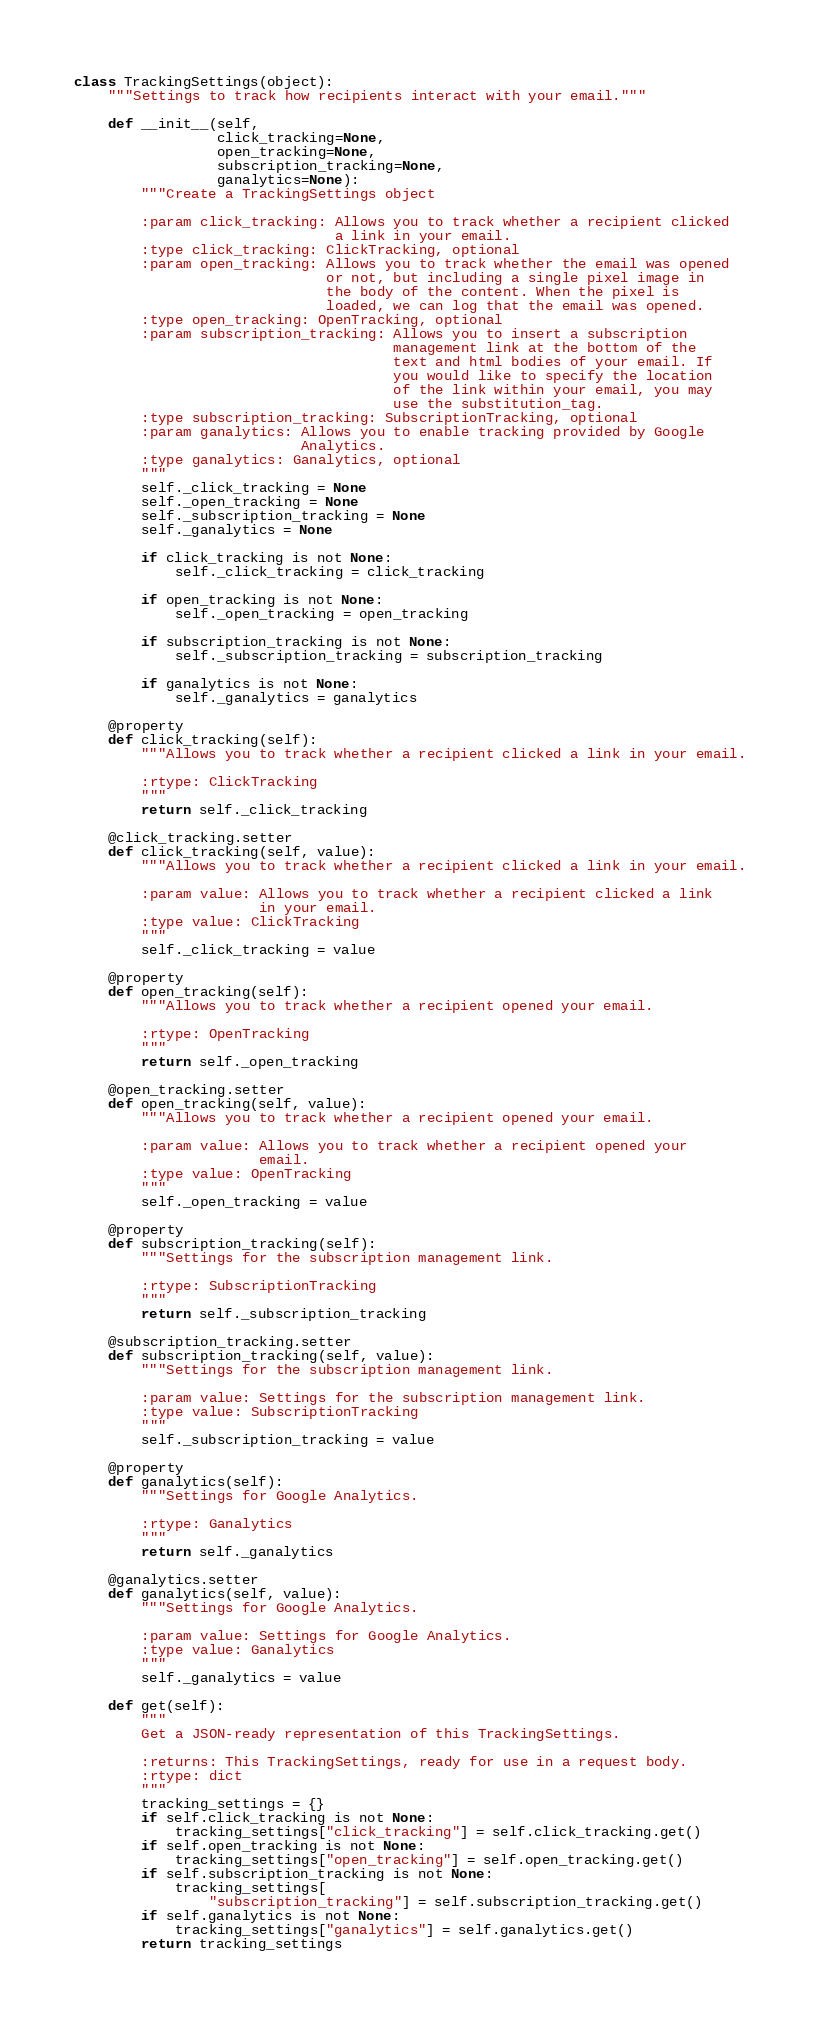Convert code to text. <code><loc_0><loc_0><loc_500><loc_500><_Python_>class TrackingSettings(object):
    """Settings to track how recipients interact with your email."""

    def __init__(self,
                 click_tracking=None,
                 open_tracking=None,
                 subscription_tracking=None,
                 ganalytics=None):
        """Create a TrackingSettings object

        :param click_tracking: Allows you to track whether a recipient clicked
                               a link in your email.
        :type click_tracking: ClickTracking, optional
        :param open_tracking: Allows you to track whether the email was opened
                              or not, but including a single pixel image in
                              the body of the content. When the pixel is
                              loaded, we can log that the email was opened.
        :type open_tracking: OpenTracking, optional
        :param subscription_tracking: Allows you to insert a subscription
                                      management link at the bottom of the
                                      text and html bodies of your email. If
                                      you would like to specify the location
                                      of the link within your email, you may
                                      use the substitution_tag.
        :type subscription_tracking: SubscriptionTracking, optional
        :param ganalytics: Allows you to enable tracking provided by Google
                           Analytics.
        :type ganalytics: Ganalytics, optional
        """
        self._click_tracking = None
        self._open_tracking = None
        self._subscription_tracking = None
        self._ganalytics = None

        if click_tracking is not None:
            self._click_tracking = click_tracking

        if open_tracking is not None:
            self._open_tracking = open_tracking

        if subscription_tracking is not None:
            self._subscription_tracking = subscription_tracking

        if ganalytics is not None:
            self._ganalytics = ganalytics

    @property
    def click_tracking(self):
        """Allows you to track whether a recipient clicked a link in your email.

        :rtype: ClickTracking
        """
        return self._click_tracking

    @click_tracking.setter
    def click_tracking(self, value):
        """Allows you to track whether a recipient clicked a link in your email.

        :param value: Allows you to track whether a recipient clicked a link
                      in your email.
        :type value: ClickTracking
        """
        self._click_tracking = value

    @property
    def open_tracking(self):
        """Allows you to track whether a recipient opened your email.

        :rtype: OpenTracking
        """
        return self._open_tracking

    @open_tracking.setter
    def open_tracking(self, value):
        """Allows you to track whether a recipient opened your email.

        :param value: Allows you to track whether a recipient opened your
                      email.
        :type value: OpenTracking
        """
        self._open_tracking = value

    @property
    def subscription_tracking(self):
        """Settings for the subscription management link.

        :rtype: SubscriptionTracking
        """
        return self._subscription_tracking

    @subscription_tracking.setter
    def subscription_tracking(self, value):
        """Settings for the subscription management link.

        :param value: Settings for the subscription management link.
        :type value: SubscriptionTracking
        """
        self._subscription_tracking = value

    @property
    def ganalytics(self):
        """Settings for Google Analytics.

        :rtype: Ganalytics
        """
        return self._ganalytics

    @ganalytics.setter
    def ganalytics(self, value):
        """Settings for Google Analytics.

        :param value: Settings for Google Analytics.
        :type value: Ganalytics
        """
        self._ganalytics = value

    def get(self):
        """
        Get a JSON-ready representation of this TrackingSettings.

        :returns: This TrackingSettings, ready for use in a request body.
        :rtype: dict
        """
        tracking_settings = {}
        if self.click_tracking is not None:
            tracking_settings["click_tracking"] = self.click_tracking.get()
        if self.open_tracking is not None:
            tracking_settings["open_tracking"] = self.open_tracking.get()
        if self.subscription_tracking is not None:
            tracking_settings[
                "subscription_tracking"] = self.subscription_tracking.get()
        if self.ganalytics is not None:
            tracking_settings["ganalytics"] = self.ganalytics.get()
        return tracking_settings
</code> 